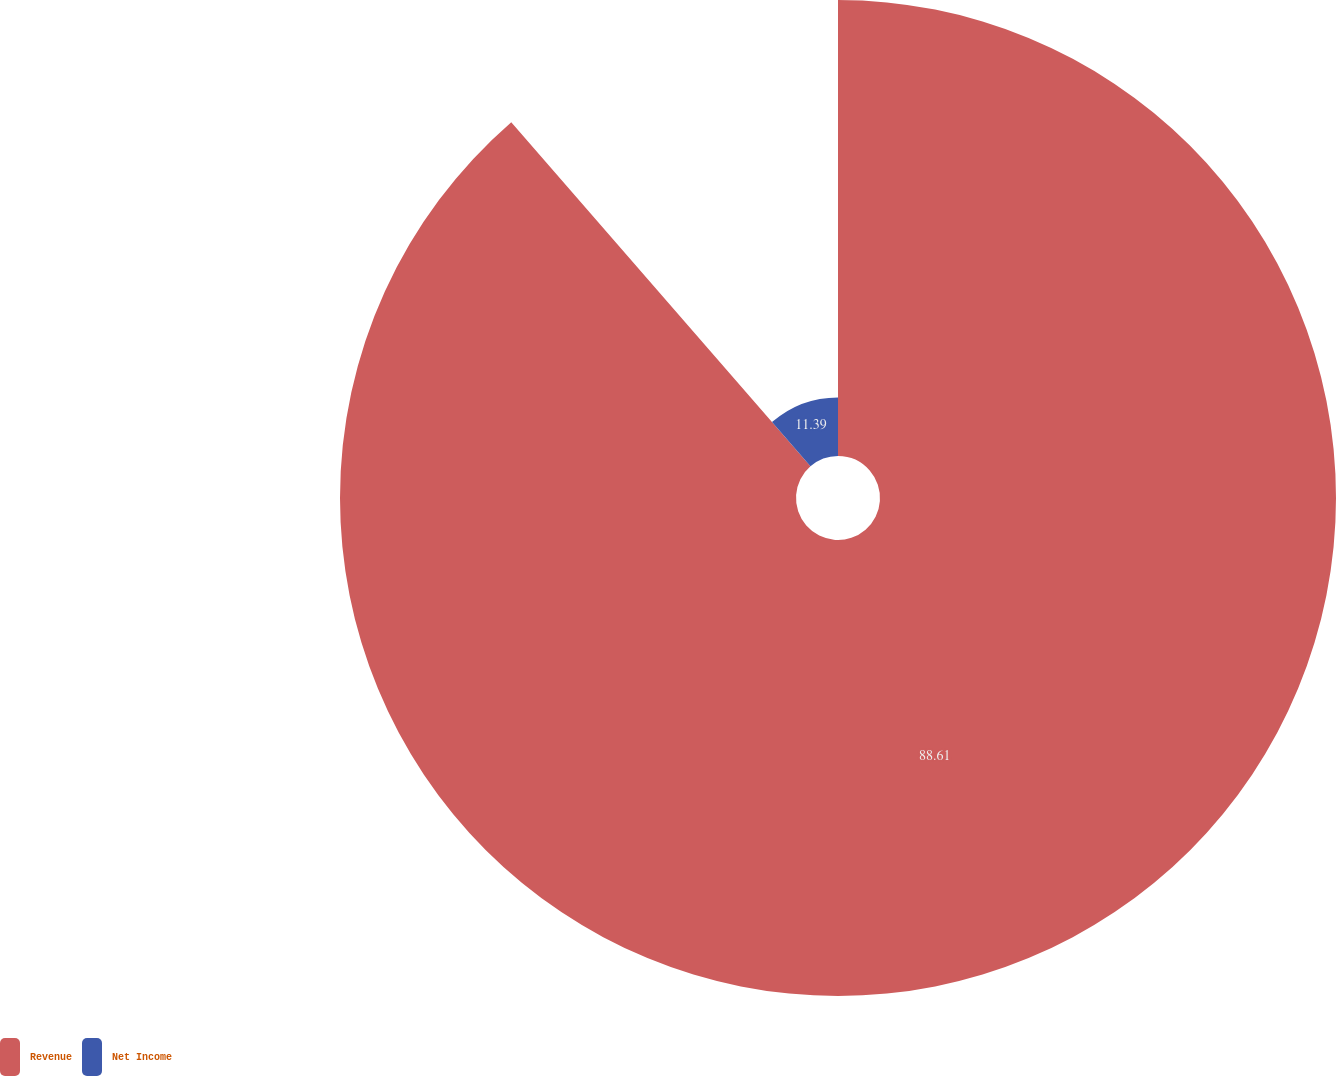Convert chart to OTSL. <chart><loc_0><loc_0><loc_500><loc_500><pie_chart><fcel>Revenue<fcel>Net Income<nl><fcel>88.61%<fcel>11.39%<nl></chart> 